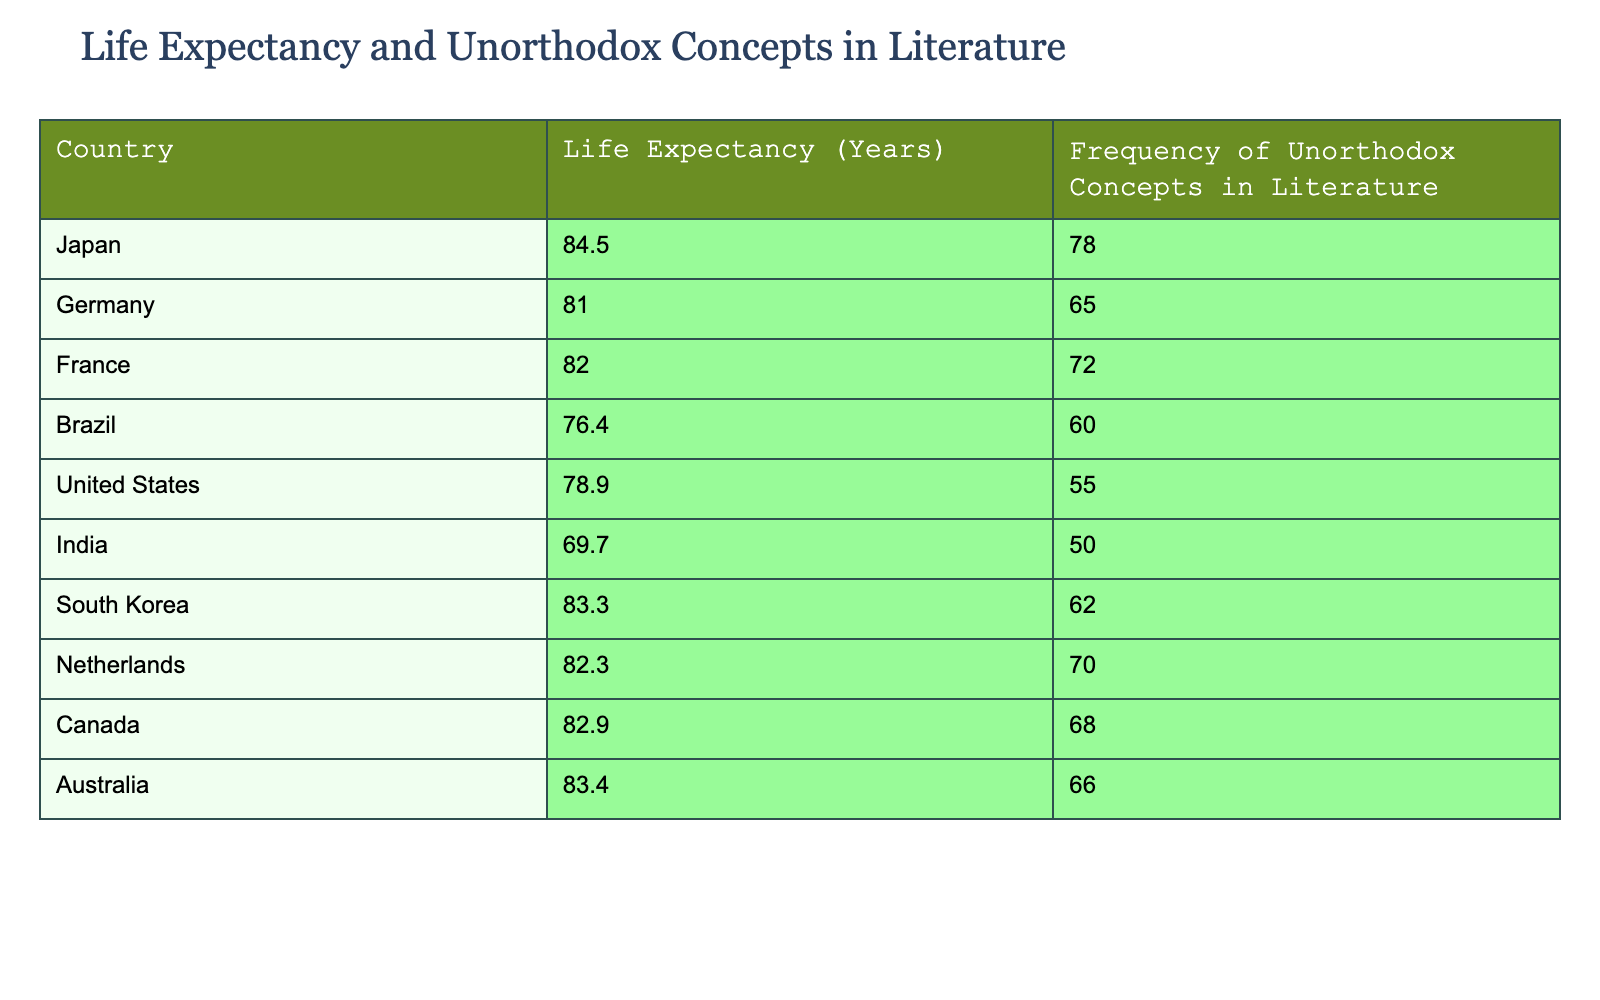What is the life expectancy of Japan? The table directly lists Japan's life expectancy as 84.5 years, which can be found in the corresponding row for Japan.
Answer: 84.5 years Which country has the highest frequency of unorthodox concepts in literature? By scanning the frequency column, Japan has the highest value listed at 78. Thus, it holds the top spot with respect to this metric.
Answer: Japan What is the average life expectancy of the countries listed in the table? To find the average, first, sum the life expectancy values: (84.5 + 81.0 + 82.0 + 76.4 + 78.9 + 69.7 + 83.3 + 82.3 + 82.9 + 83.4) = 825.4. Then, divide by the number of countries (10): 825.4 / 10 = 82.54.
Answer: 82.54 years Does Germany have a higher life expectancy than South Korea? Germany's life expectancy is 81.0 years, while South Korea's is 83.3 years. Since 81.0 is less than 83.3, the statement is false.
Answer: No What is the difference in life expectancy between the country with the highest and lowest values? The highest life expectancy is Japan at 84.5 years and the lowest is India at 69.7 years. The difference can be calculated as 84.5 - 69.7 = 14.8 years.
Answer: 14.8 years Which country among Brazil and Canada has a higher frequency of unorthodox concepts in literature? Looking at the values, Brazil has a frequency of 60, while Canada has 68. Since 68 is greater than 60, Canada has a higher frequency.
Answer: Canada What percentage of countries listed have a life expectancy greater than 80 years? There are 6 countries with life expectancies greater than 80 years (Japan, France, South Korea, Netherlands, Canada, Australia) out of 10 total countries. To calculate the percentage, (6 / 10) * 100 = 60%.
Answer: 60% Is the average frequency of unorthodox concepts in literature for countries with life expectancy above 80 also above 70? The countries with life expectancy above 80 are Japan, France, South Korea, Netherlands, Canada, and Australia, which have frequencies 78, 72, 62, 70, 68, and 66 respectively. The average is (78 + 72 + 62 + 70 + 68 + 66) / 6 = 70.33, which is greater than 70, making the statement true.
Answer: Yes What is the sum of the life expectancy for Germany and the United States? The life expectancy for Germany is 81.0 years and for the United States, it is 78.9 years. Summing these values gives 81.0 + 78.9 = 159.9 years.
Answer: 159.9 years 